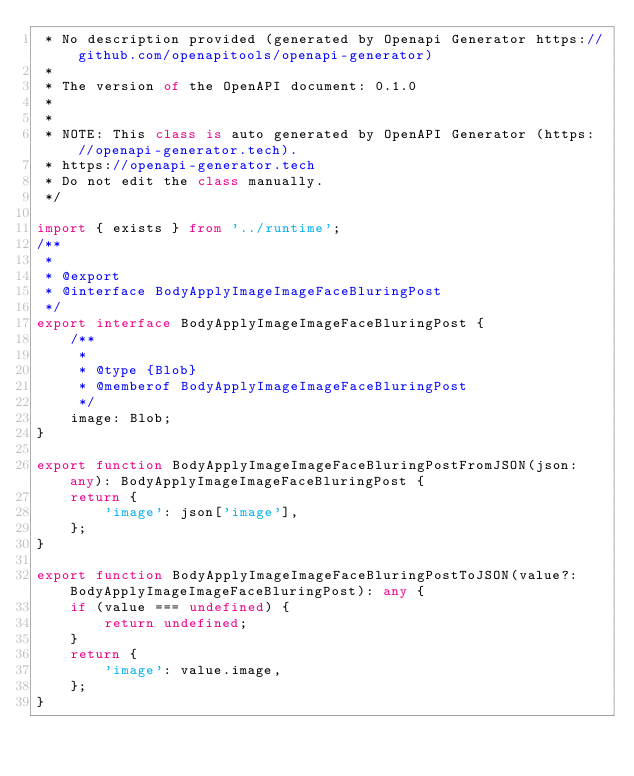<code> <loc_0><loc_0><loc_500><loc_500><_TypeScript_> * No description provided (generated by Openapi Generator https://github.com/openapitools/openapi-generator)
 *
 * The version of the OpenAPI document: 0.1.0
 * 
 *
 * NOTE: This class is auto generated by OpenAPI Generator (https://openapi-generator.tech).
 * https://openapi-generator.tech
 * Do not edit the class manually.
 */

import { exists } from '../runtime';
/**
 * 
 * @export
 * @interface BodyApplyImageImageFaceBluringPost
 */
export interface BodyApplyImageImageFaceBluringPost {
    /**
     * 
     * @type {Blob}
     * @memberof BodyApplyImageImageFaceBluringPost
     */
    image: Blob;
}

export function BodyApplyImageImageFaceBluringPostFromJSON(json: any): BodyApplyImageImageFaceBluringPost {
    return {
        'image': json['image'],
    };
}

export function BodyApplyImageImageFaceBluringPostToJSON(value?: BodyApplyImageImageFaceBluringPost): any {
    if (value === undefined) {
        return undefined;
    }
    return {
        'image': value.image,
    };
}


</code> 